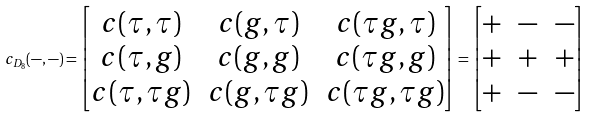<formula> <loc_0><loc_0><loc_500><loc_500>c _ { D _ { 8 } } ( - , - ) = \begin{bmatrix} c ( \tau , \tau ) & c ( g , \tau ) & c ( \tau g , \tau ) \\ c ( \tau , g ) & c ( g , g ) & c ( \tau g , g ) \\ c ( \tau , \tau g ) & c ( g , \tau g ) & c ( \tau g , \tau g ) \\ \end{bmatrix} = \begin{bmatrix} + & - & - \\ + & + & + \\ + & - & - \end{bmatrix}</formula> 